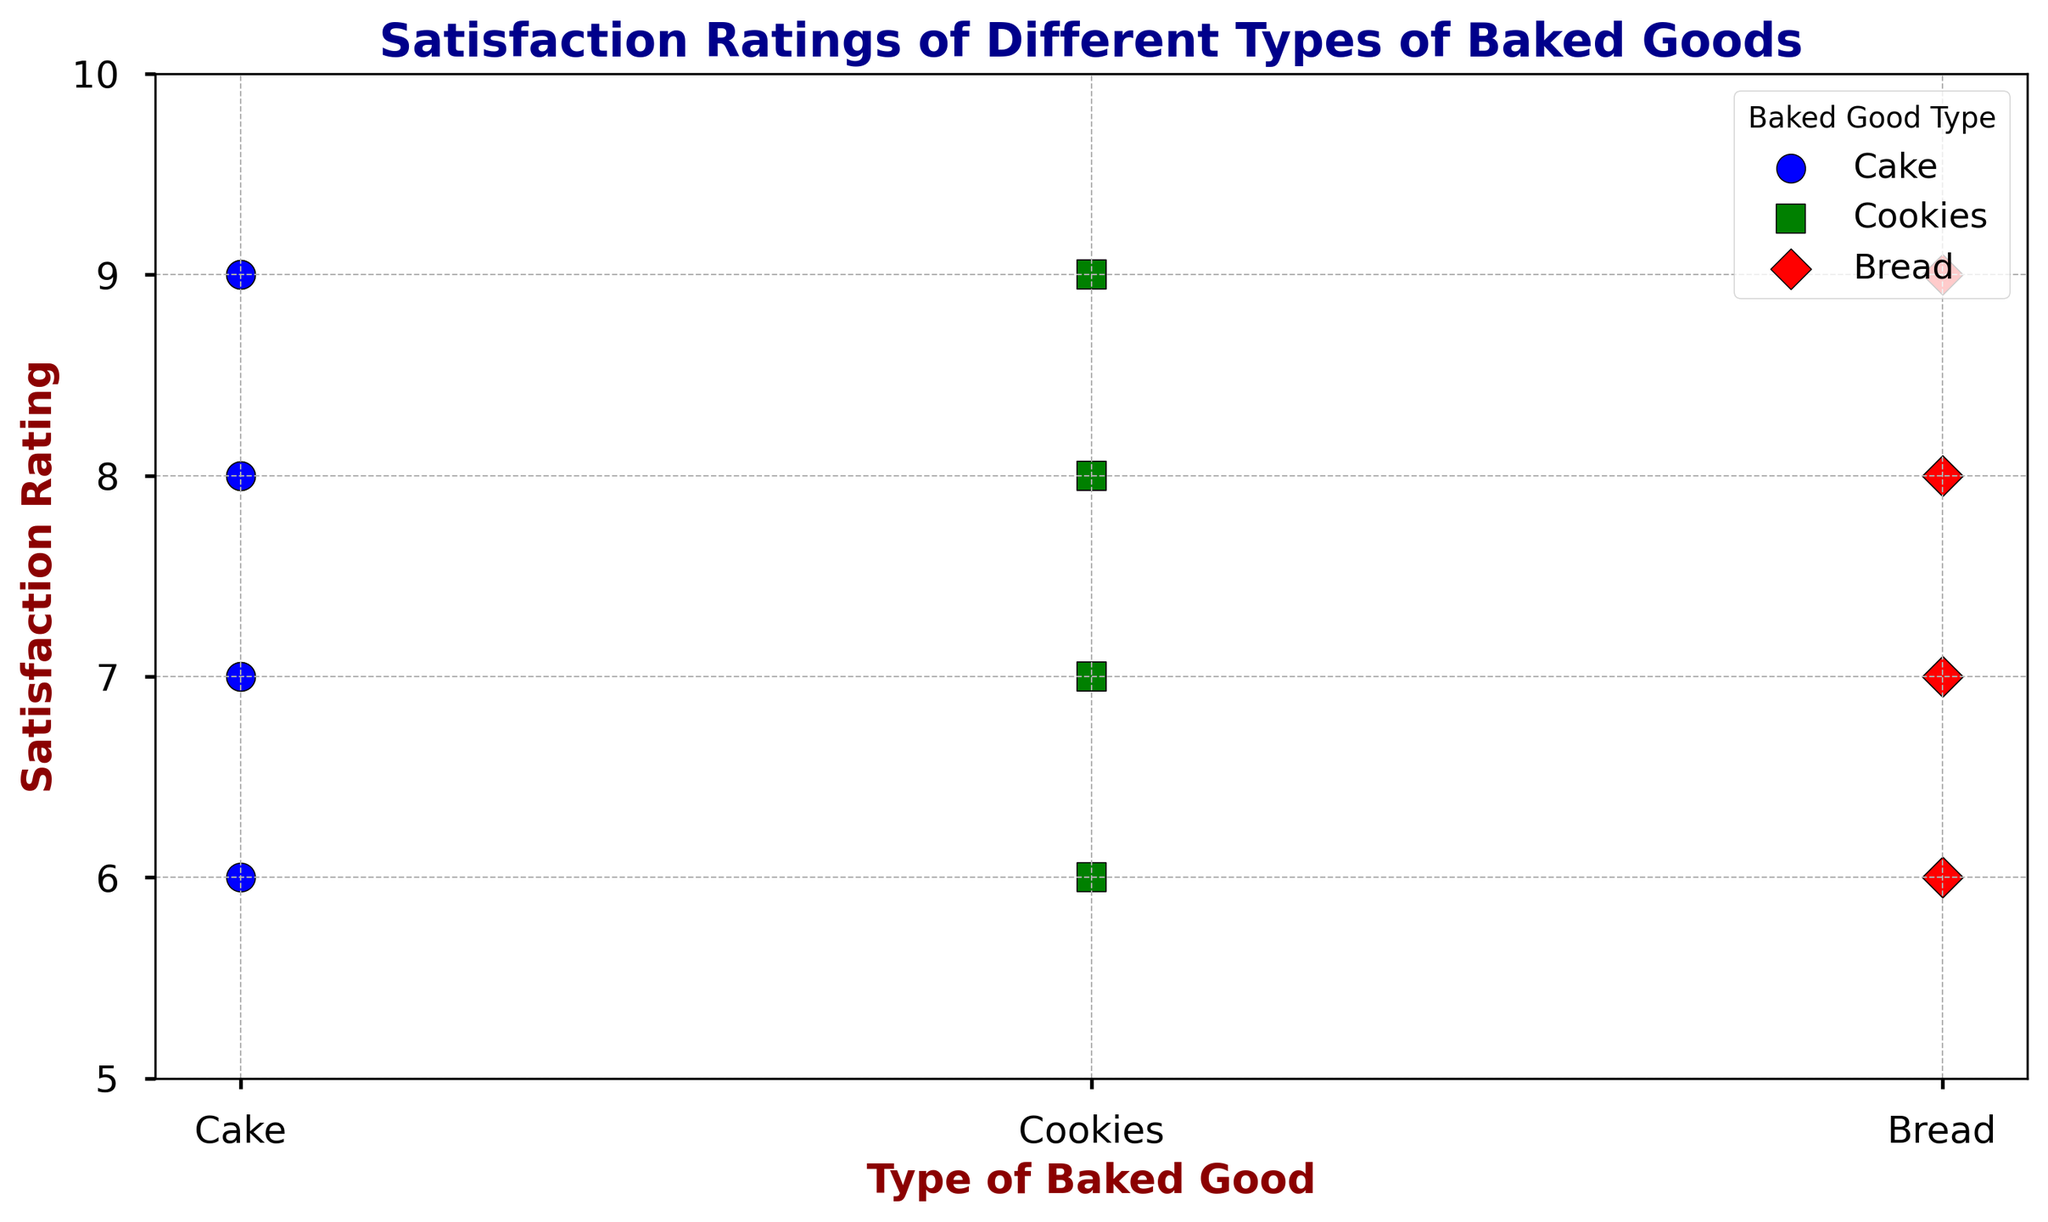What type of baked good had the highest satisfaction rating? From the plot, we can see the various satisfaction ratings for each type of baked good. The highest satisfaction rating is for Bread, which has a rating of 9. There is no other type of baked good with a higher rating than 9.
Answer: Bread Which type of baked good has the most data points clustered around a satisfaction rating of 8? By examining the scatter plot, we notice that both Cake and Cookies have multiple points around a satisfaction rating of 8. But Cookies has slightly more points right at the rating of 8.
Answer: Cookies What is the average satisfaction rating for Cakes? Looking at the plot, the satisfaction ratings for Cakes are 9, 7, 6, 8, 9, 7, 8. Adding these ratings: 9+7+6+8+9+7+8=54. There are 7 ratings, so the average is 54/7 = 7.71.
Answer: 7.71 Which type of baked good has the most variable satisfaction ratings? Observing the scatter plot, Cakes have a wide range of ratings from 6 to 9, while Cookies and Bread have a more narrow distribution. Thus, Cakes show the most variability.
Answer: Cakes For Bread, how many data points have a satisfaction rating lower than 7? On the scatter plot, we can see ratings of Bread, with two points having ratings of 6, and others 7 or higher. Therefore, there are two data points for Bread with ratings lower than 7.
Answer: 2 Which type of baked good has the most consistent satisfaction ratings? From the scatter plot, we observe that Bread and Cookies have more uniform ratings, but Bread’s ratings are more strictly within a narrow band of 6 to 9 with the median clustering tightly.
Answer: Bread How many baked goods types are represented in the scatter plot? Observing the different markers and labels in the scatter plot legend, it mentions Cakes, Cookies, and Bread, making it a total of three types of baked goods represented.
Answer: 3 Among the Bakers, who produced the baked goods with an average satisfaction rating closer to 8? By reviewing the plot, both Cake and Cookies have lots of ratings around 7-9, giving them averages hovering around 7.71 (for Cake) and 7.67 (for Cookies). Bread tilts around the same values of 7.22. Cake and Cookies are closer to 8, but Cakes have more points right at 8, thus tilting closer overall.
Answer: Cake How many times does the satisfaction rating hit exactly 9 for Cookies? By counting the points on the scatter plot specifically for Cookies at 9, we see there are three instances where the rating is exactly 9.
Answer: 3 